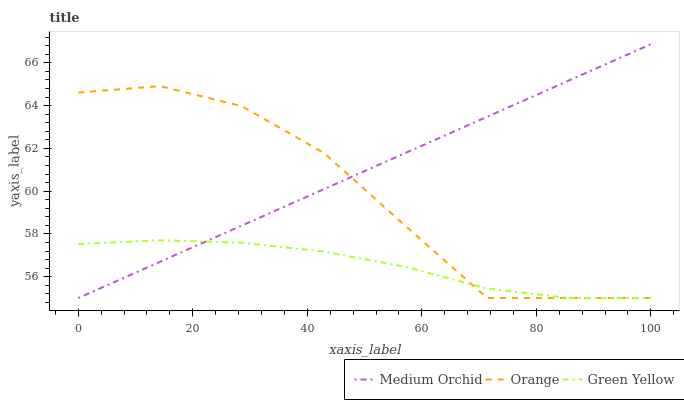Does Green Yellow have the minimum area under the curve?
Answer yes or no. Yes. Does Medium Orchid have the maximum area under the curve?
Answer yes or no. Yes. Does Medium Orchid have the minimum area under the curve?
Answer yes or no. No. Does Green Yellow have the maximum area under the curve?
Answer yes or no. No. Is Medium Orchid the smoothest?
Answer yes or no. Yes. Is Orange the roughest?
Answer yes or no. Yes. Is Green Yellow the smoothest?
Answer yes or no. No. Is Green Yellow the roughest?
Answer yes or no. No. Does Orange have the lowest value?
Answer yes or no. Yes. Does Medium Orchid have the highest value?
Answer yes or no. Yes. Does Green Yellow have the highest value?
Answer yes or no. No. Does Green Yellow intersect Medium Orchid?
Answer yes or no. Yes. Is Green Yellow less than Medium Orchid?
Answer yes or no. No. Is Green Yellow greater than Medium Orchid?
Answer yes or no. No. 